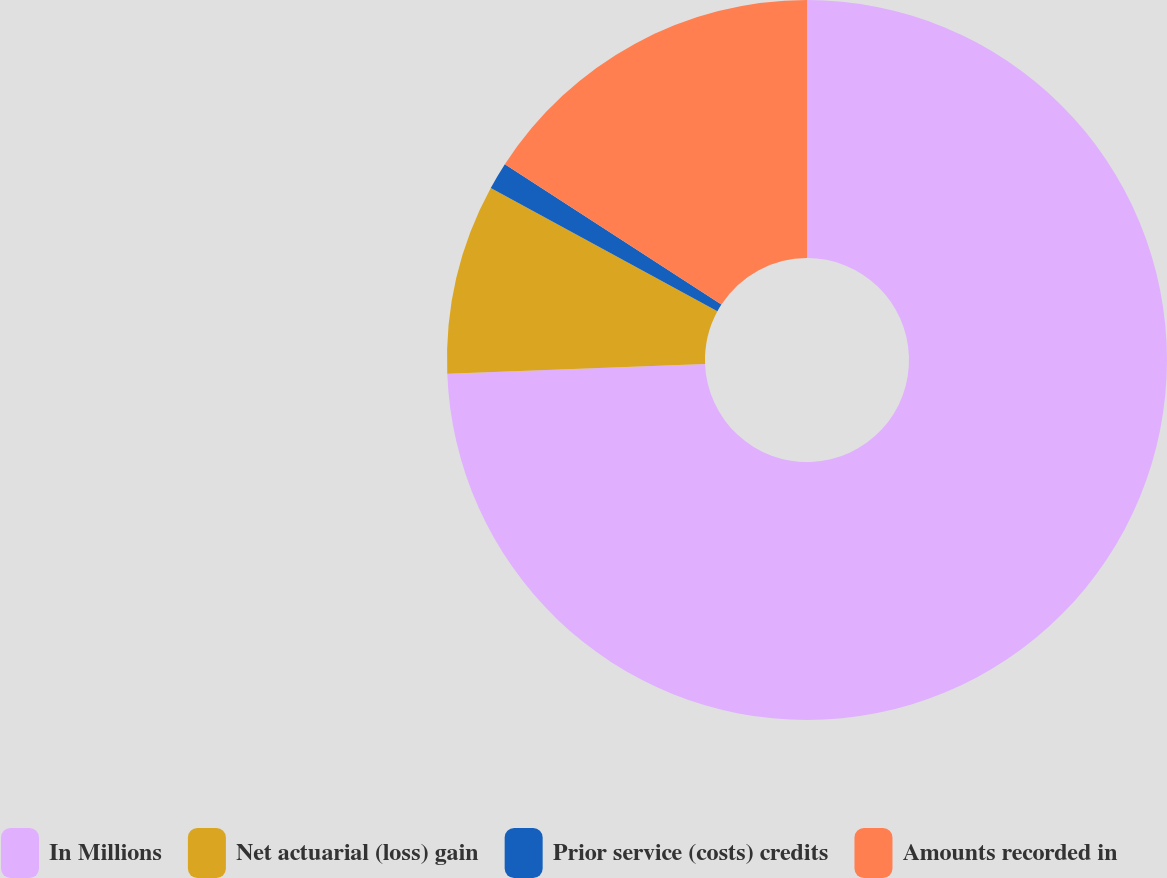<chart> <loc_0><loc_0><loc_500><loc_500><pie_chart><fcel>In Millions<fcel>Net actuarial (loss) gain<fcel>Prior service (costs) credits<fcel>Amounts recorded in<nl><fcel>74.39%<fcel>8.54%<fcel>1.22%<fcel>15.85%<nl></chart> 